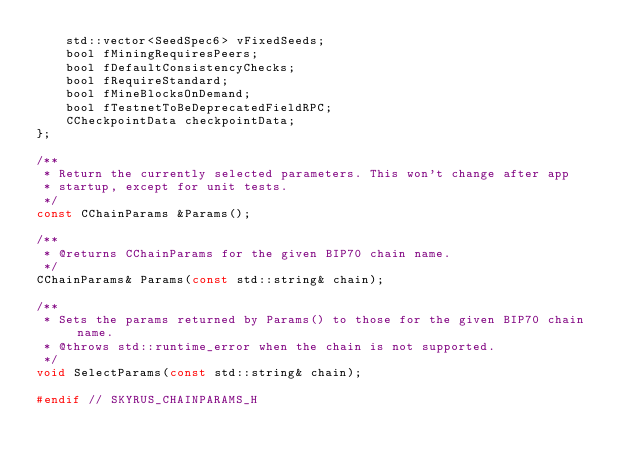<code> <loc_0><loc_0><loc_500><loc_500><_C_>    std::vector<SeedSpec6> vFixedSeeds;
    bool fMiningRequiresPeers;
    bool fDefaultConsistencyChecks;
    bool fRequireStandard;
    bool fMineBlocksOnDemand;
    bool fTestnetToBeDeprecatedFieldRPC;
    CCheckpointData checkpointData;
};

/**
 * Return the currently selected parameters. This won't change after app
 * startup, except for unit tests.
 */
const CChainParams &Params();

/**
 * @returns CChainParams for the given BIP70 chain name.
 */
CChainParams& Params(const std::string& chain);

/**
 * Sets the params returned by Params() to those for the given BIP70 chain name.
 * @throws std::runtime_error when the chain is not supported.
 */
void SelectParams(const std::string& chain);

#endif // SKYRUS_CHAINPARAMS_H
</code> 